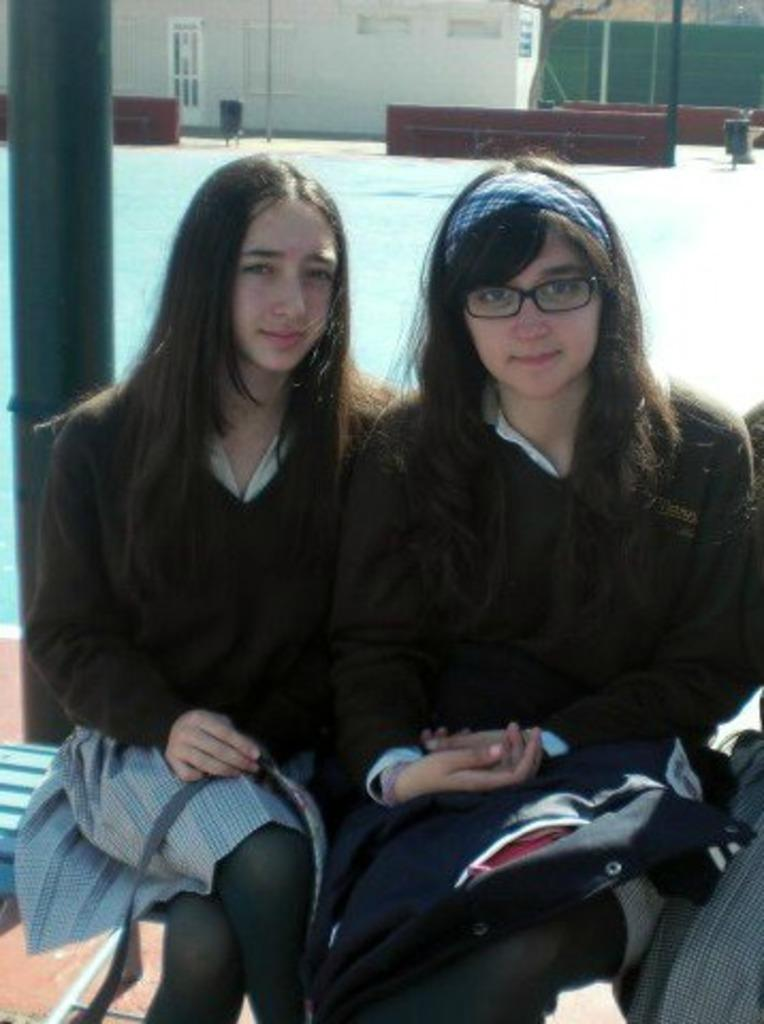How many women are sitting on the bench in the image? There are two women sitting on a bench in the image. Can you describe one of the women's appearance? One of the women is wearing spectacles. What can be seen in the background of the image? In the background of the image, there are poles, a door, a window, a wall, and water visible. What type of laborer is working on the ghost in the image? There is no laborer or ghost present in the image. 